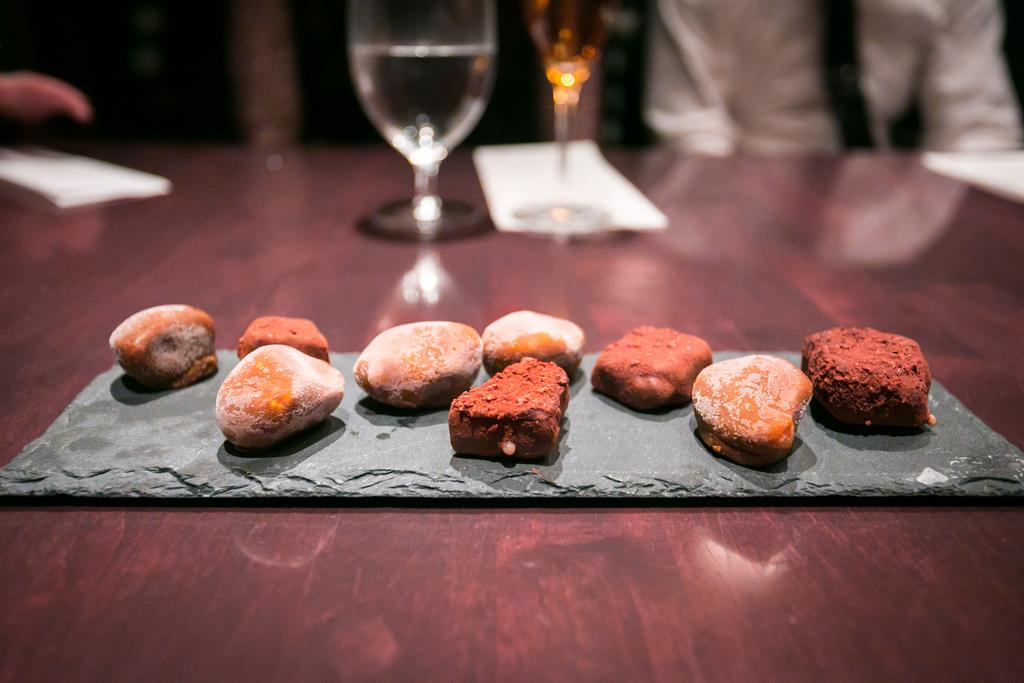What is contained in the glasses that are visible in the image? There are glasses with liquid in the image. What can be used for cleaning or wiping in the image? Tissue papers are present in the image for cleaning or wiping. What other objects can be seen on the table in the image? There are other objects on the table in the image, but their specific details are not mentioned in the provided facts. Can you describe the person visible in the image? A person is visible at the top of the image, but only partially, so their appearance cannot be described in detail. What type of house is visible in the image? There is no house present in the image; it only features glasses with liquid, tissue papers, and other objects on a table. How does the person in the image participate in the afterthought? There is no afterthought depicted in the image, and the person's actions or thoughts cannot be determined. 